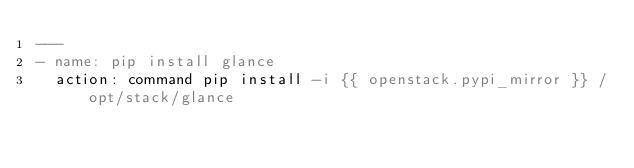Convert code to text. <code><loc_0><loc_0><loc_500><loc_500><_YAML_>---
- name: pip install glance
  action: command pip install -i {{ openstack.pypi_mirror }} /opt/stack/glance
</code> 